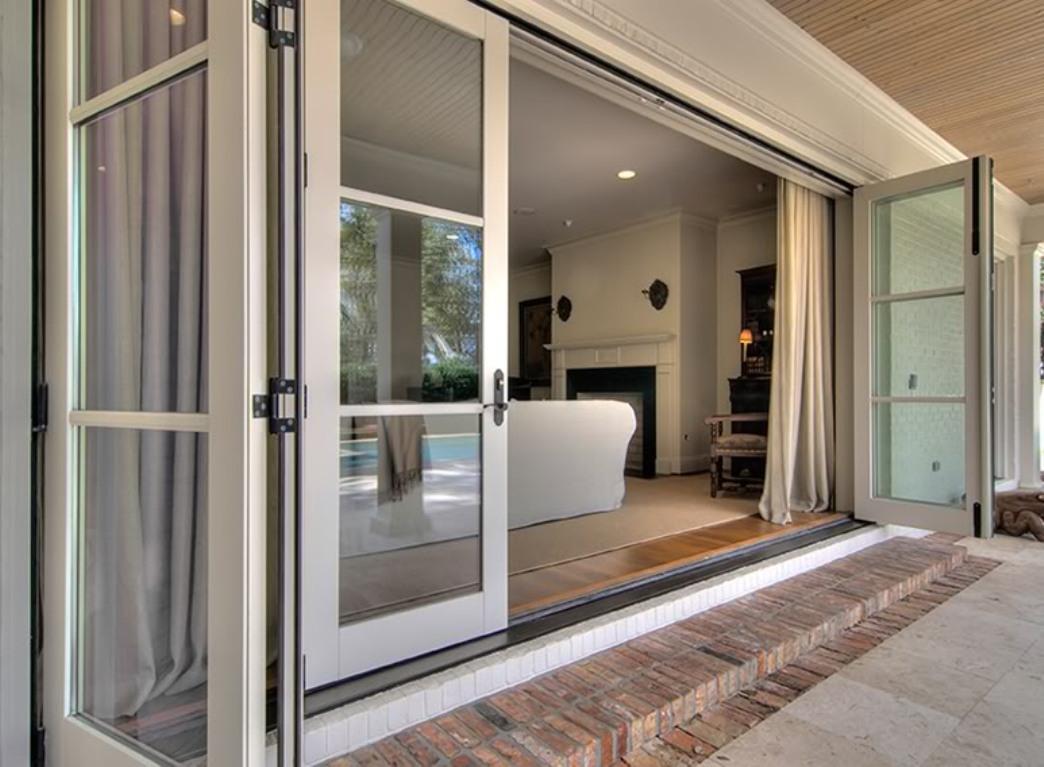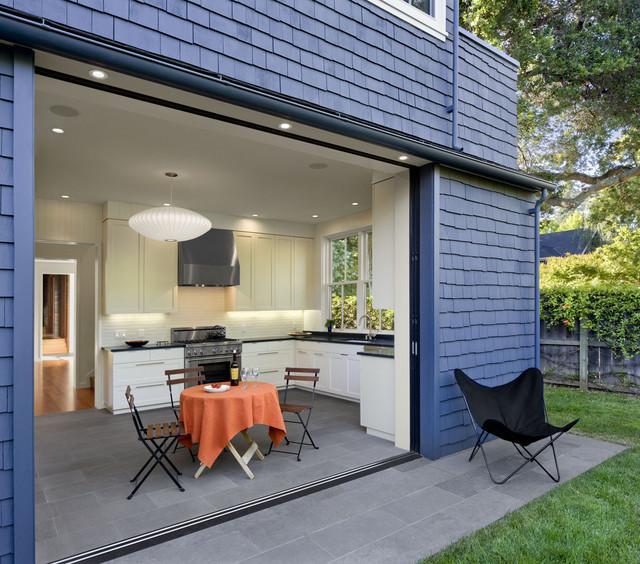The first image is the image on the left, the second image is the image on the right. Considering the images on both sides, is "At least one door has white trim." valid? Answer yes or no. Yes. The first image is the image on the left, the second image is the image on the right. Examine the images to the left and right. Is the description "There are two exterior views of open glass panels that open to the outside." accurate? Answer yes or no. No. 